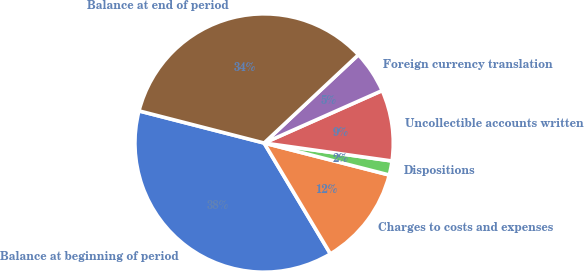<chart> <loc_0><loc_0><loc_500><loc_500><pie_chart><fcel>Balance at beginning of period<fcel>Charges to costs and expenses<fcel>Dispositions<fcel>Uncollectible accounts written<fcel>Foreign currency translation<fcel>Balance at end of period<nl><fcel>37.59%<fcel>12.44%<fcel>1.76%<fcel>8.88%<fcel>5.32%<fcel>34.03%<nl></chart> 